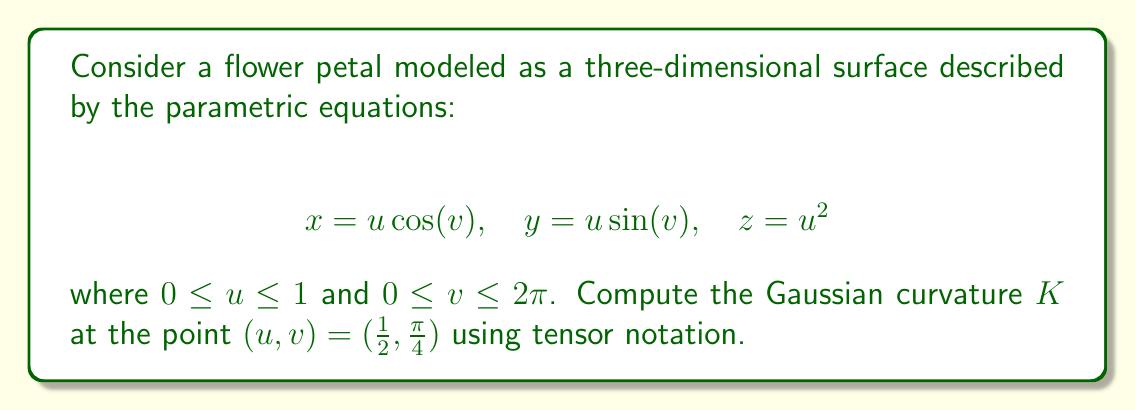Give your solution to this math problem. Let's approach this step-by-step:

1) First, we need to calculate the metric tensor $g_{ij}$ and its inverse $g^{ij}$. The components of the metric tensor are given by:

   $$g_{ij} = \frac{\partial \mathbf{r}}{\partial u^i} \cdot \frac{\partial \mathbf{r}}{\partial u^j}$$

   where $\mathbf{r} = (x,y,z)$ and $(u^1, u^2) = (u,v)$.

2) Calculate the partial derivatives:

   $$\frac{\partial \mathbf{r}}{\partial u} = (\cos(v), \sin(v), 2u)$$
   $$\frac{\partial \mathbf{r}}{\partial v} = (-u\sin(v), u\cos(v), 0)$$

3) Now we can compute $g_{ij}$:

   $$g_{11} = \cos^2(v) + \sin^2(v) + 4u^2 = 1 + 4u^2$$
   $$g_{12} = g_{21} = 0$$
   $$g_{22} = u^2$$

4) The inverse metric tensor $g^{ij}$ is:

   $$g^{11} = \frac{1}{1+4u^2}, \quad g^{12} = g^{21} = 0, \quad g^{22} = \frac{1}{u^2}$$

5) Next, we need to calculate the Christoffel symbols:

   $$\Gamma^k_{ij} = \frac{1}{2}g^{kl}(\frac{\partial g_{il}}{\partial u^j} + \frac{\partial g_{jl}}{\partial u^i} - \frac{\partial g_{ij}}{\partial u^l})$$

6) The non-zero Christoffel symbols are:

   $$\Gamma^1_{11} = \frac{4u}{1+4u^2}, \quad \Gamma^1_{22} = -\frac{u}{1+4u^2}, \quad \Gamma^2_{12} = \Gamma^2_{21} = \frac{1}{u}$$

7) Now we can calculate the Riemann curvature tensor:

   $$R^i_{jkl} = \frac{\partial \Gamma^i_{jl}}{\partial u^k} - \frac{\partial \Gamma^i_{jk}}{\partial u^l} + \Gamma^i_{mk}\Gamma^m_{jl} - \Gamma^i_{ml}\Gamma^m_{jk}$$

8) The only non-zero component is:

   $$R^1_{212} = -\frac{4}{(1+4u^2)^2}$$

9) The Gaussian curvature is given by:

   $$K = \frac{R^1_{212}R^2_{121}}{g_{11}g_{22} - g_{12}^2} = \frac{R^1_{212}}{g_{11}}$$

10) Substituting $u = \frac{1}{2}$:

    $$K = -\frac{4}{(1+4(\frac{1}{2})^2)^2} \cdot \frac{1}{1+4(\frac{1}{2})^2} = -\frac{4}{2^2} \cdot \frac{1}{2} = -\frac{1}{2}$$

Therefore, the Gaussian curvature at the point $(u,v) = (\frac{1}{2}, \frac{\pi}{4})$ is $-\frac{1}{2}$.
Answer: $K = -\frac{1}{2}$ 